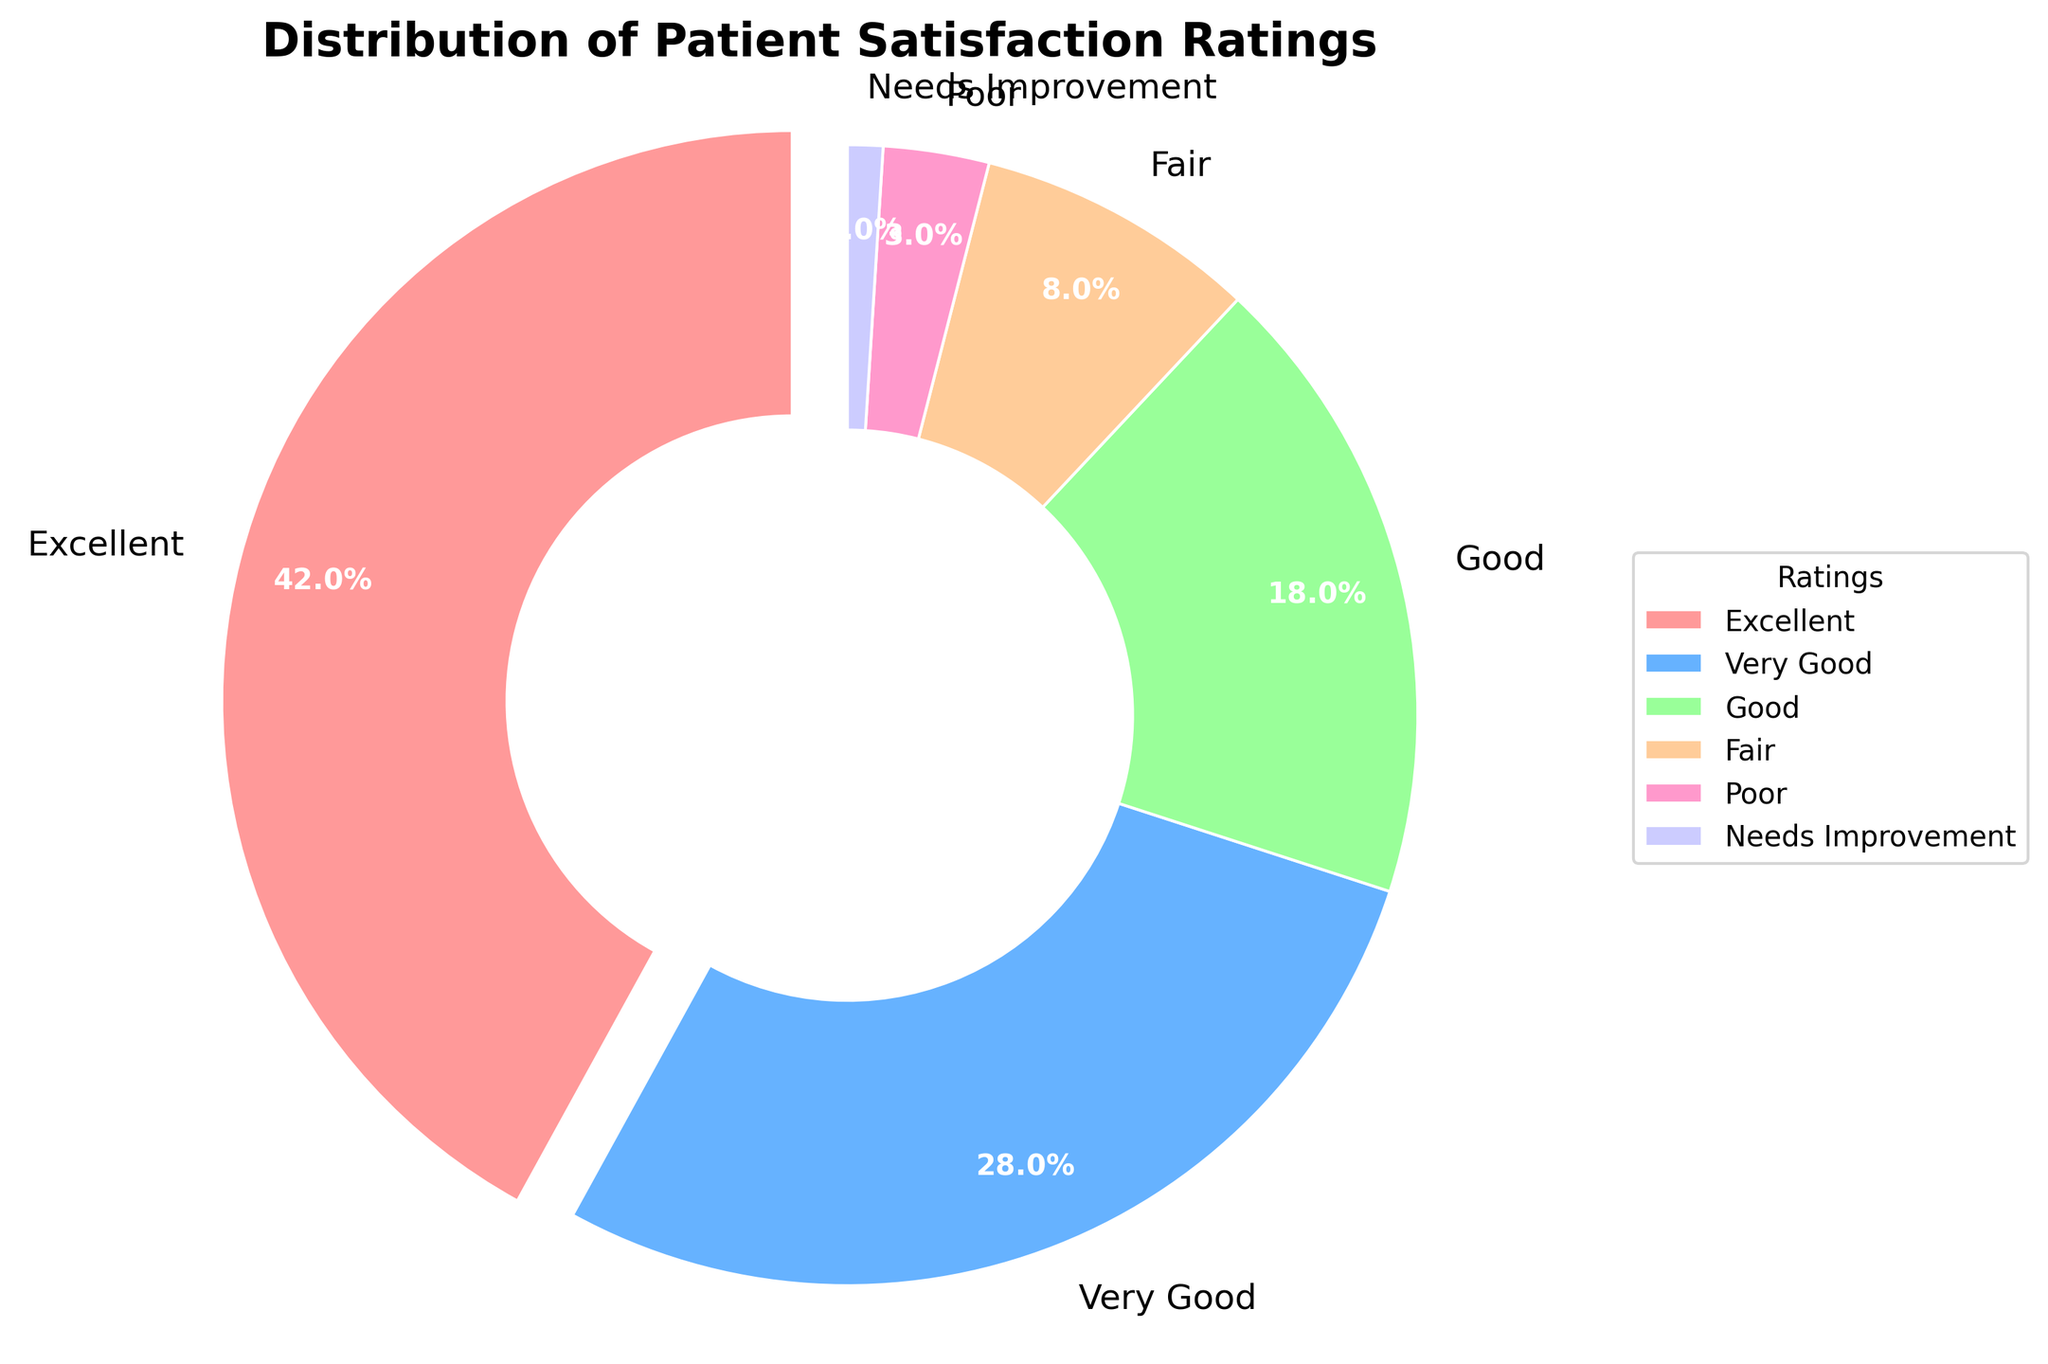What percentage of patients rated their satisfaction as 'Very Good'? According to the pie chart, the segment labeled 'Very Good' represents 28% of the total distribution.
Answer: 28% Which rating category accounts for the smallest portion of patient satisfaction? The wedge with the smallest percentage is labeled 'Needs Improvement', which accounts for 1% of the total.
Answer: Needs Improvement What is the combined percentage of patients who rated their satisfaction as 'Excellent' and 'Very Good'? To find the combined percentage, add the percentage of 'Excellent' (42%) to 'Very Good' (28%). The total is 42% + 28% = 70%.
Answer: 70% Which segment has the highest percentage, and what is that percentage? The 'Excellent' segment has the highest percentage, representing 42% of the total patient satisfaction ratings.
Answer: Excellent, 42% How does the percentage of patients who rated their satisfaction as 'Good' compare to those who rated it as 'Fair'? The percentage for 'Good' is 18%, while 'Fair' is 8%. Therefore, 'Good' is higher by 18% - 8% = 10%.
Answer: Good is higher by 10% What are the total percentages of patients whose satisfaction ratings are 'Fair' or 'Poor'? To find the total percentage for 'Fair' and 'Poor', add their percentages: 'Fair' (8%) + 'Poor' (3%) = 8% + 3% = 11%.
Answer: 11% What proportion of the ratings is 'Excellent' compared to 'Needs Improvement'? The percentage for 'Excellent' is 42%, whereas for 'Needs Improvement' it is 1%. The proportion is 42/1 = 42.
Answer: 42 times Which ratings together make up less than 10% of the total? Adding 'Needs Improvement' (1%) and 'Poor' (3%) results in 4%, and adding 'Fair' (8%) results in 12%. Therefore, it is only 'Needs Improvement' and 'Poor' that together make up less than 10%.
Answer: Needs Improvement and Poor If 1000 patients were surveyed, how many rated their satisfaction as 'Fair'? 8% of 1000 patients would have rated their satisfaction as 'Fair'. Calculation: 1000 * 0.08 = 80.
Answer: 80 